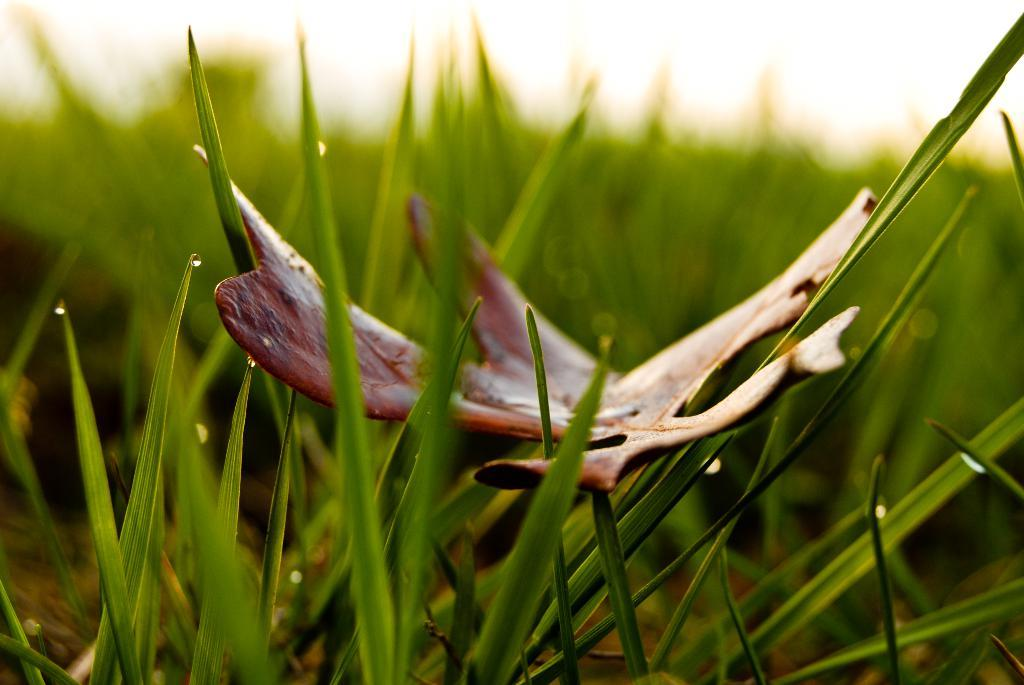What type of vegetation is present in the image? There is grass in the picture. What other natural element can be seen in the image? There is a leaf in the picture. How would you describe the background of the image? The background of the image is blurred. What color is the scarf draped over the fork in the image? There is no scarf or fork present in the image. 